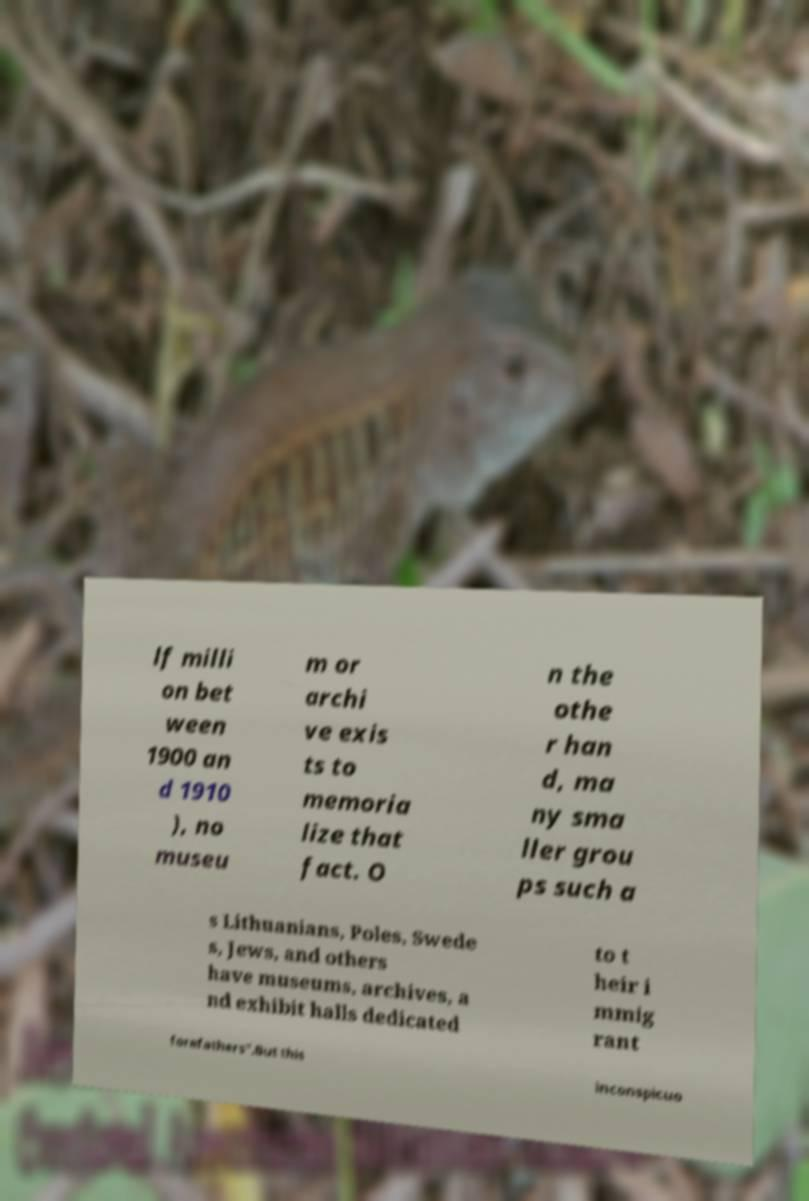Can you accurately transcribe the text from the provided image for me? lf milli on bet ween 1900 an d 1910 ), no museu m or archi ve exis ts to memoria lize that fact. O n the othe r han d, ma ny sma ller grou ps such a s Lithuanians, Poles, Swede s, Jews, and others have museums, archives, a nd exhibit halls dedicated to t heir i mmig rant forefathers".But this inconspicuo 